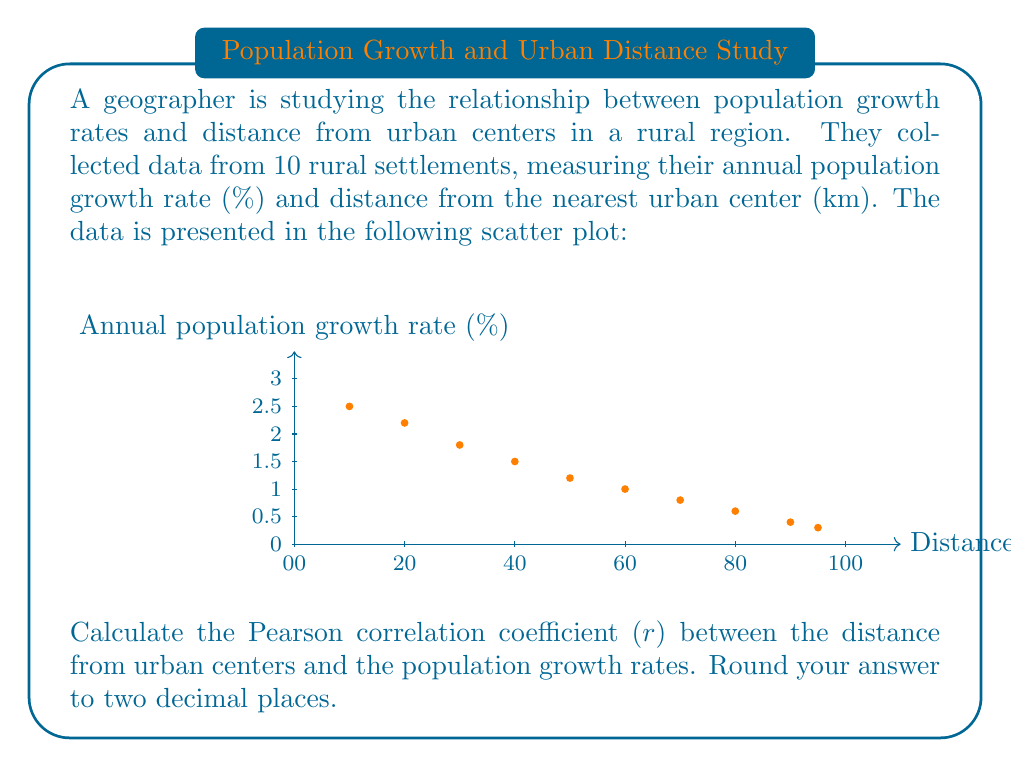Could you help me with this problem? To calculate the Pearson correlation coefficient (r), we'll follow these steps:

1. Calculate the means of x (distance) and y (growth rate):
   $\bar{x} = \frac{\sum x_i}{n} = \frac{10+20+30+40+50+60+70+80+90+95}{10} = 54.5$ km
   $\bar{y} = \frac{\sum y_i}{n} = \frac{2.5+2.2+1.8+1.5+1.2+1.0+0.8+0.6+0.4+0.3}{10} = 1.23$ %

2. Calculate the deviations from the means:
   $x_i - \bar{x}$ and $y_i - \bar{y}$ for each data point

3. Calculate the products of the deviations:
   $(x_i - \bar{x})(y_i - \bar{y})$ for each data point

4. Sum the products of deviations:
   $\sum (x_i - \bar{x})(y_i - \bar{y})$

5. Calculate the sum of squared deviations for x and y:
   $\sum (x_i - \bar{x})^2$ and $\sum (y_i - \bar{y})^2$

6. Apply the formula for Pearson correlation coefficient:

   $$r = \frac{\sum (x_i - \bar{x})(y_i - \bar{y})}{\sqrt{\sum (x_i - \bar{x})^2 \sum (y_i - \bar{y})^2}}$$

Calculating these values:

$\sum (x_i - \bar{x})(y_i - \bar{y}) = -1638.625$
$\sum (x_i - \bar{x})^2 = 16012.25$
$\sum (y_i - \bar{y})^2 = 4.2491$

Plugging into the formula:

$$r = \frac{-1638.625}{\sqrt{16012.25 \times 4.2491}} = -0.9951$$

Rounding to two decimal places: $r = -0.99$
Answer: $-0.99$ 